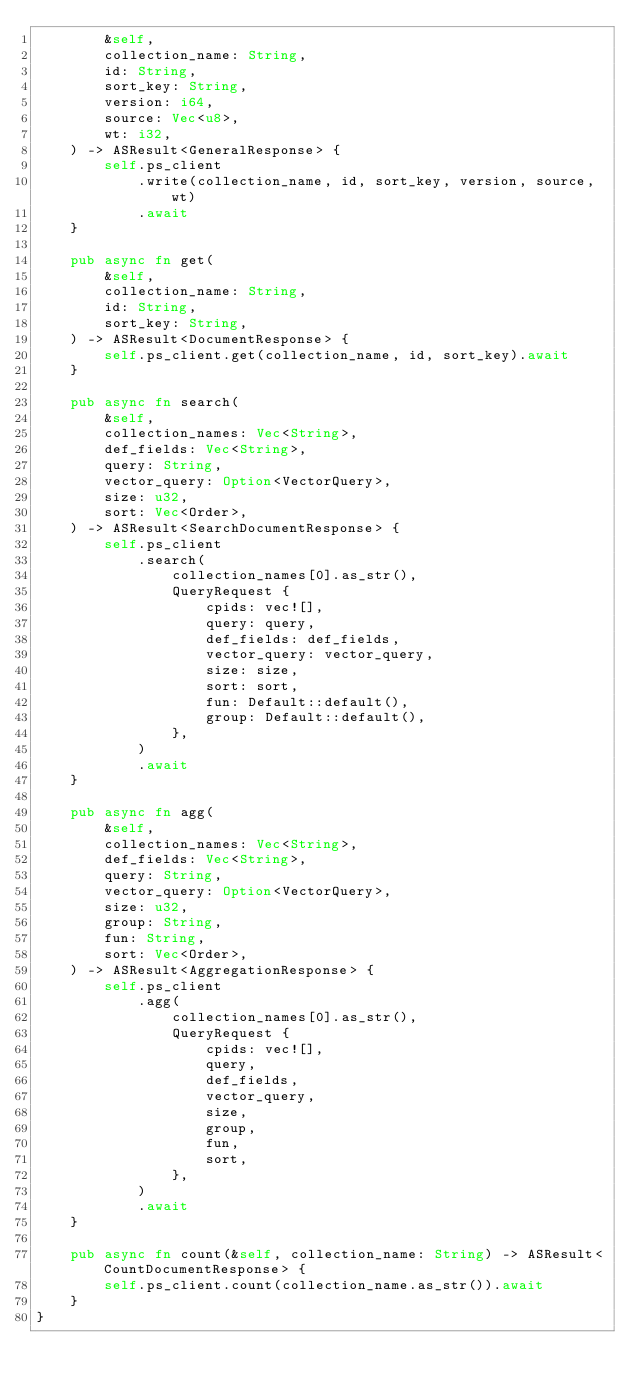<code> <loc_0><loc_0><loc_500><loc_500><_Rust_>        &self,
        collection_name: String,
        id: String,
        sort_key: String,
        version: i64,
        source: Vec<u8>,
        wt: i32,
    ) -> ASResult<GeneralResponse> {
        self.ps_client
            .write(collection_name, id, sort_key, version, source, wt)
            .await
    }

    pub async fn get(
        &self,
        collection_name: String,
        id: String,
        sort_key: String,
    ) -> ASResult<DocumentResponse> {
        self.ps_client.get(collection_name, id, sort_key).await
    }

    pub async fn search(
        &self,
        collection_names: Vec<String>,
        def_fields: Vec<String>,
        query: String,
        vector_query: Option<VectorQuery>,
        size: u32,
        sort: Vec<Order>,
    ) -> ASResult<SearchDocumentResponse> {
        self.ps_client
            .search(
                collection_names[0].as_str(),
                QueryRequest {
                    cpids: vec![],
                    query: query,
                    def_fields: def_fields,
                    vector_query: vector_query,
                    size: size,
                    sort: sort,
                    fun: Default::default(),
                    group: Default::default(),
                },
            )
            .await
    }

    pub async fn agg(
        &self,
        collection_names: Vec<String>,
        def_fields: Vec<String>,
        query: String,
        vector_query: Option<VectorQuery>,
        size: u32,
        group: String,
        fun: String,
        sort: Vec<Order>,
    ) -> ASResult<AggregationResponse> {
        self.ps_client
            .agg(
                collection_names[0].as_str(),
                QueryRequest {
                    cpids: vec![],
                    query,
                    def_fields,
                    vector_query,
                    size,
                    group,
                    fun,
                    sort,
                },
            )
            .await
    }

    pub async fn count(&self, collection_name: String) -> ASResult<CountDocumentResponse> {
        self.ps_client.count(collection_name.as_str()).await
    }
}
</code> 